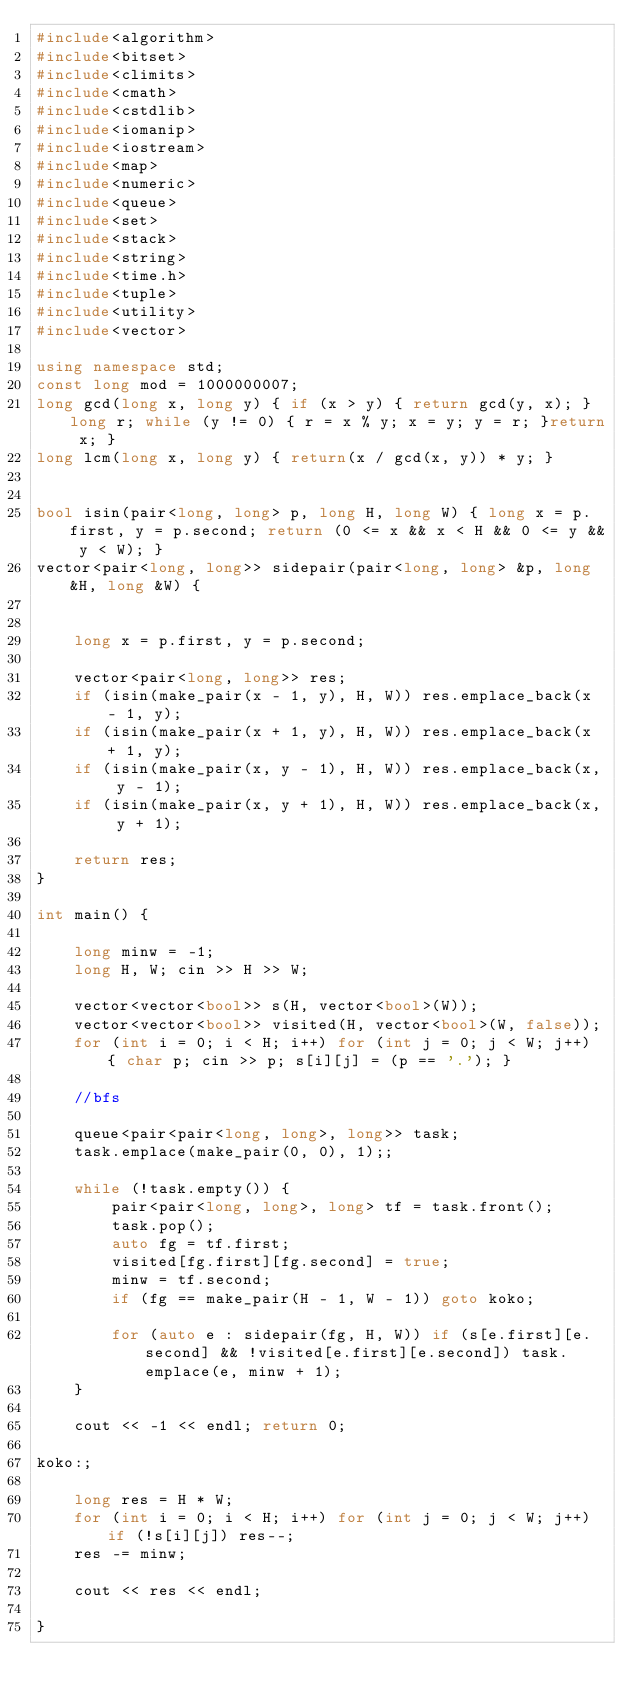Convert code to text. <code><loc_0><loc_0><loc_500><loc_500><_C++_>#include<algorithm>
#include<bitset>
#include<climits>
#include<cmath>
#include<cstdlib>
#include<iomanip>
#include<iostream>
#include<map>
#include<numeric>
#include<queue>
#include<set>
#include<stack>
#include<string>
#include<time.h>
#include<tuple>
#include<utility>
#include<vector>

using namespace std;
const long mod = 1000000007;
long gcd(long x, long y) { if (x > y) { return gcd(y, x); } long r; while (y != 0) { r = x % y; x = y; y = r; }return x; }
long lcm(long x, long y) { return(x / gcd(x, y)) * y; }


bool isin(pair<long, long> p, long H, long W) { long x = p.first, y = p.second; return (0 <= x && x < H && 0 <= y && y < W); }
vector<pair<long, long>> sidepair(pair<long, long> &p, long &H, long &W) {


	long x = p.first, y = p.second;
	
	vector<pair<long, long>> res;
	if (isin(make_pair(x - 1, y), H, W)) res.emplace_back(x - 1, y);
	if (isin(make_pair(x + 1, y), H, W)) res.emplace_back(x + 1, y);
	if (isin(make_pair(x, y - 1), H, W)) res.emplace_back(x, y - 1);
	if (isin(make_pair(x, y + 1), H, W)) res.emplace_back(x, y + 1);

	return res;
}

int main() {

	long minw = -1;
	long H, W; cin >> H >> W;

	vector<vector<bool>> s(H, vector<bool>(W));
	vector<vector<bool>> visited(H, vector<bool>(W, false));
	for (int i = 0; i < H; i++) for (int j = 0; j < W; j++) { char p; cin >> p; s[i][j] = (p == '.'); }

	//bfs

	queue<pair<pair<long, long>, long>> task;
	task.emplace(make_pair(0, 0), 1);;

	while (!task.empty()) {
		pair<pair<long, long>, long> tf = task.front();
		task.pop();
		auto fg = tf.first;
		visited[fg.first][fg.second] = true;
		minw = tf.second;
		if (fg == make_pair(H - 1, W - 1)) goto koko;

		for (auto e : sidepair(fg, H, W)) if (s[e.first][e.second] && !visited[e.first][e.second]) task.emplace(e, minw + 1);
	}

	cout << -1 << endl; return 0;

koko:;

	long res = H * W;
	for (int i = 0; i < H; i++) for (int j = 0; j < W; j++) if (!s[i][j]) res--;
	res -= minw;

	cout << res << endl;

}</code> 